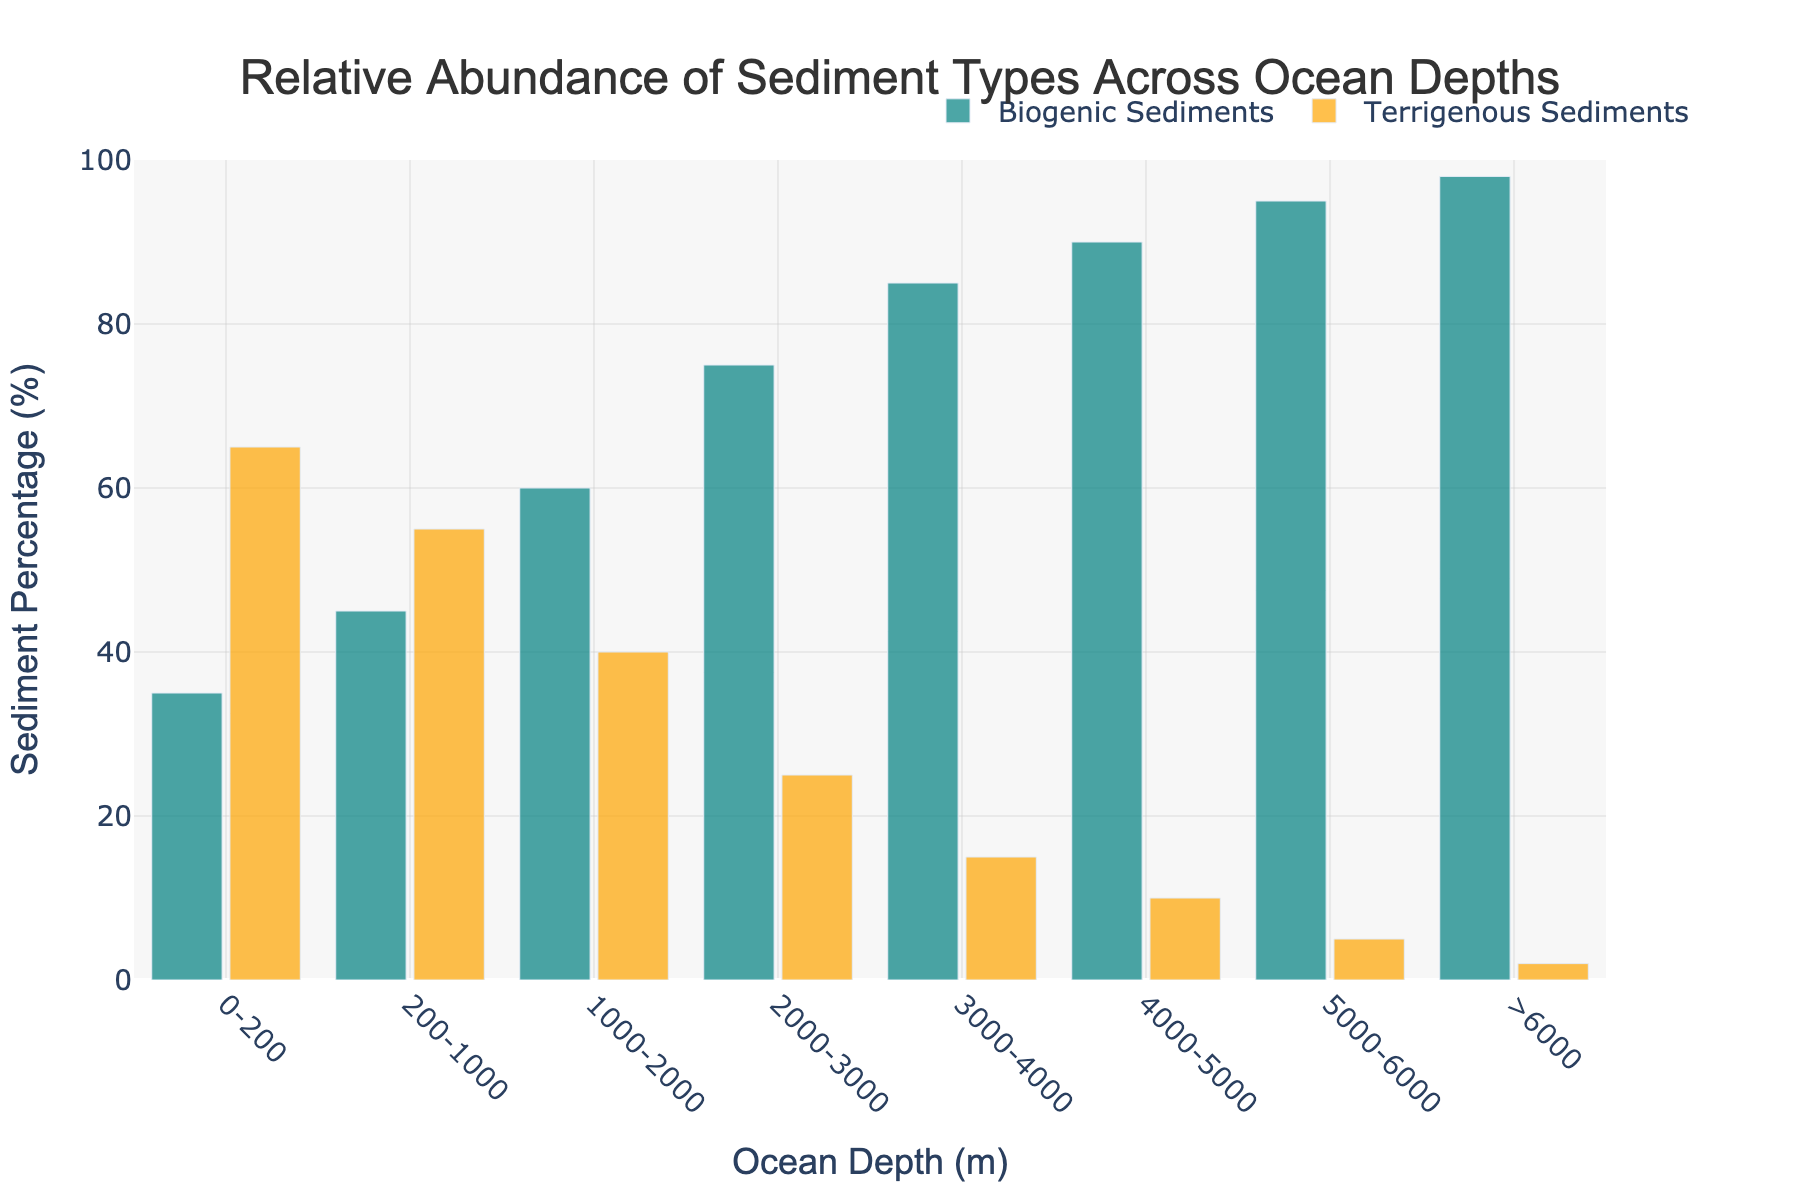What's the percentage of terrigenous sediments at 2000-3000 meters ocean depth? Check the height of the orange bar corresponding to the 2000-3000 meters range. This bar reaches up to 25%.
Answer: 25% Which sediment type is more abundant at 0-200 meters? Compare the two bars at 0-200 meters. The orange bar for terrigenous sediments is taller than the teal bar for biogenic sediments.
Answer: Terrigenous sediments How does the percentage of biogenic sediments change from 1000-2000 meters to 3000-4000 meters? Look at the biogenic sediments' bars for these depths. They increase from 60% at 1000-2000 meters to 85% at 3000-4000 meters. The change is 85% - 60% = 25%.
Answer: Increases by 25% What is the average percentage of biogenic sediments across all depth ranges? Calculate the sum of the biogenic percentages for all depth ranges and then divide by the number of ranges: (35 + 45 + 60 + 75 + 85 + 90 + 95 + 98) / 8 = 71.625%
Answer: 71.625% What is the difference in terrigenous sediments percentage between 4000-5000 meters and >6000 meters? Subtract the percentage at >6000 meters from that at 4000-5000 meters: 10% - 2% = 8%
Answer: 8% At what depth does biogenic sediment reach its highest percentage? Identify the tallest teal bar. The biogenic sediment reaches its highest percentage (>6000 meters) at 98%.
Answer: >6000 meters Which depth range has a more balanced ratio of biogenic and terrigenous sediments? Look for depth ranges where the bars are closer in height. The 200-1000 meters range has values of 45% biogenic and 55% terrigenous, which is more balanced than other ranges.
Answer: 200-1000 meters 